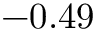Convert formula to latex. <formula><loc_0><loc_0><loc_500><loc_500>- 0 . 4 9</formula> 